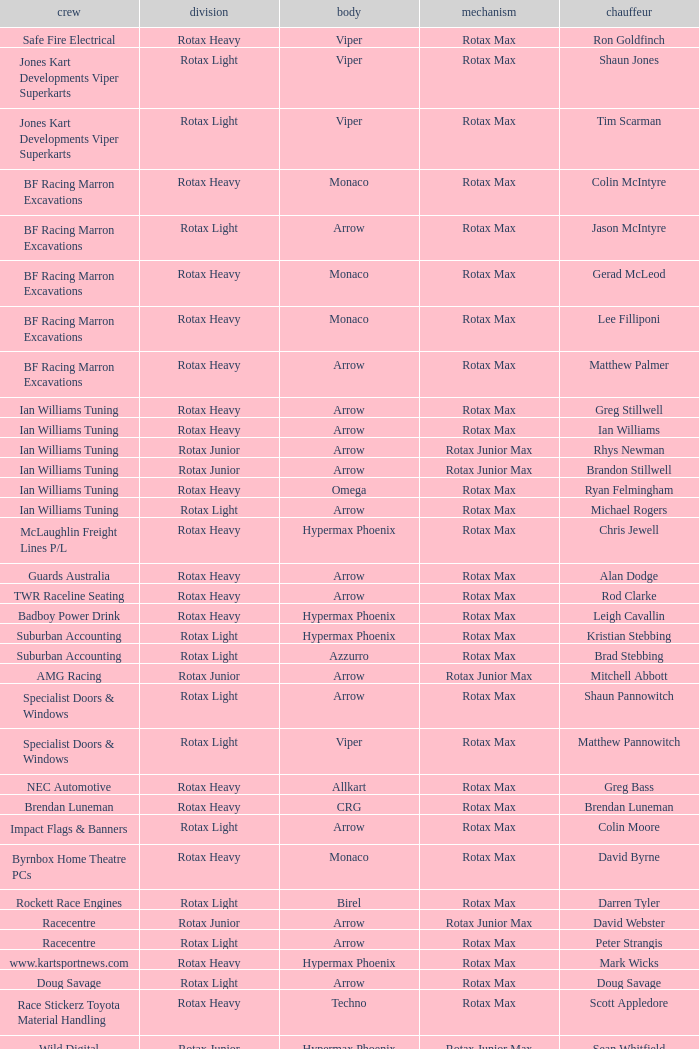What type of engine does the BF Racing Marron Excavations have that also has Monaco as chassis and Lee Filliponi as the driver? Rotax Max. 